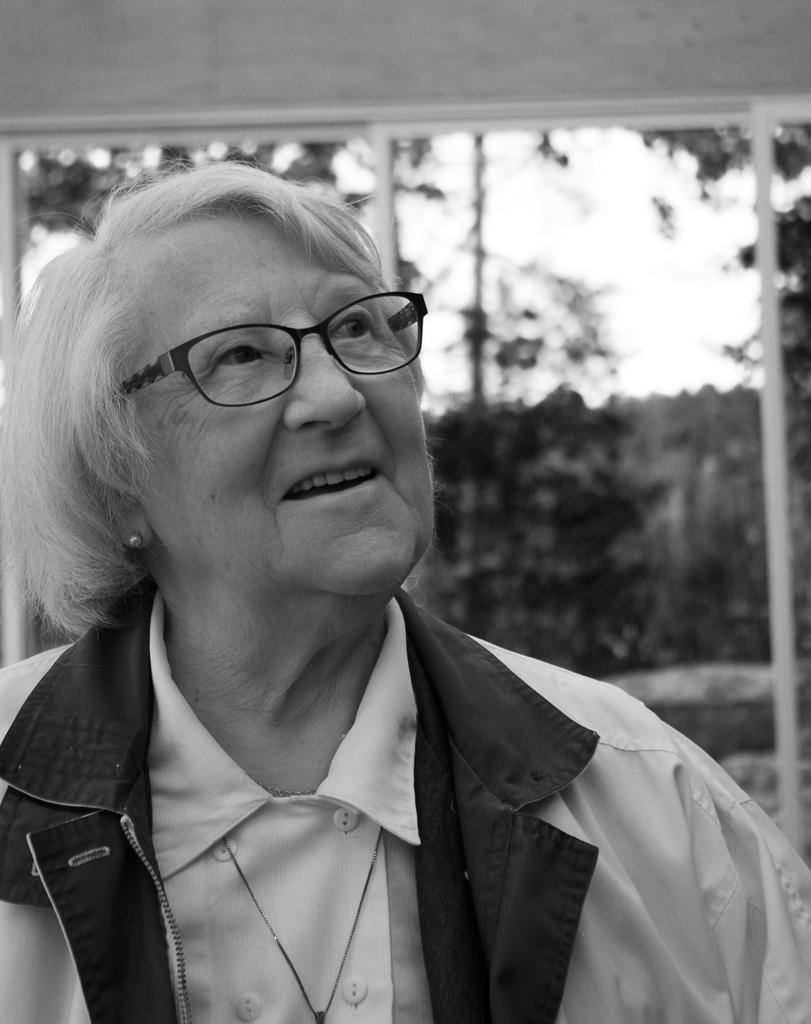Who is present in the image? There is a woman in the image. What is the woman wearing? The woman is wearing a white jacket. What is the woman's facial expression? The woman is smiling. What can be seen in the background of the image? There are white color poles, a wall, trees, and clouds in the sky. How are the poles positioned in the image? The poles are attached to a wall in the background. What type of bean is being used to make the bread in the image? There is no bread or beans present in the image. How does the woman feel in the image? The woman's facial expression suggests that she is feeling comfortable, but the image does not explicitly state her emotions. 